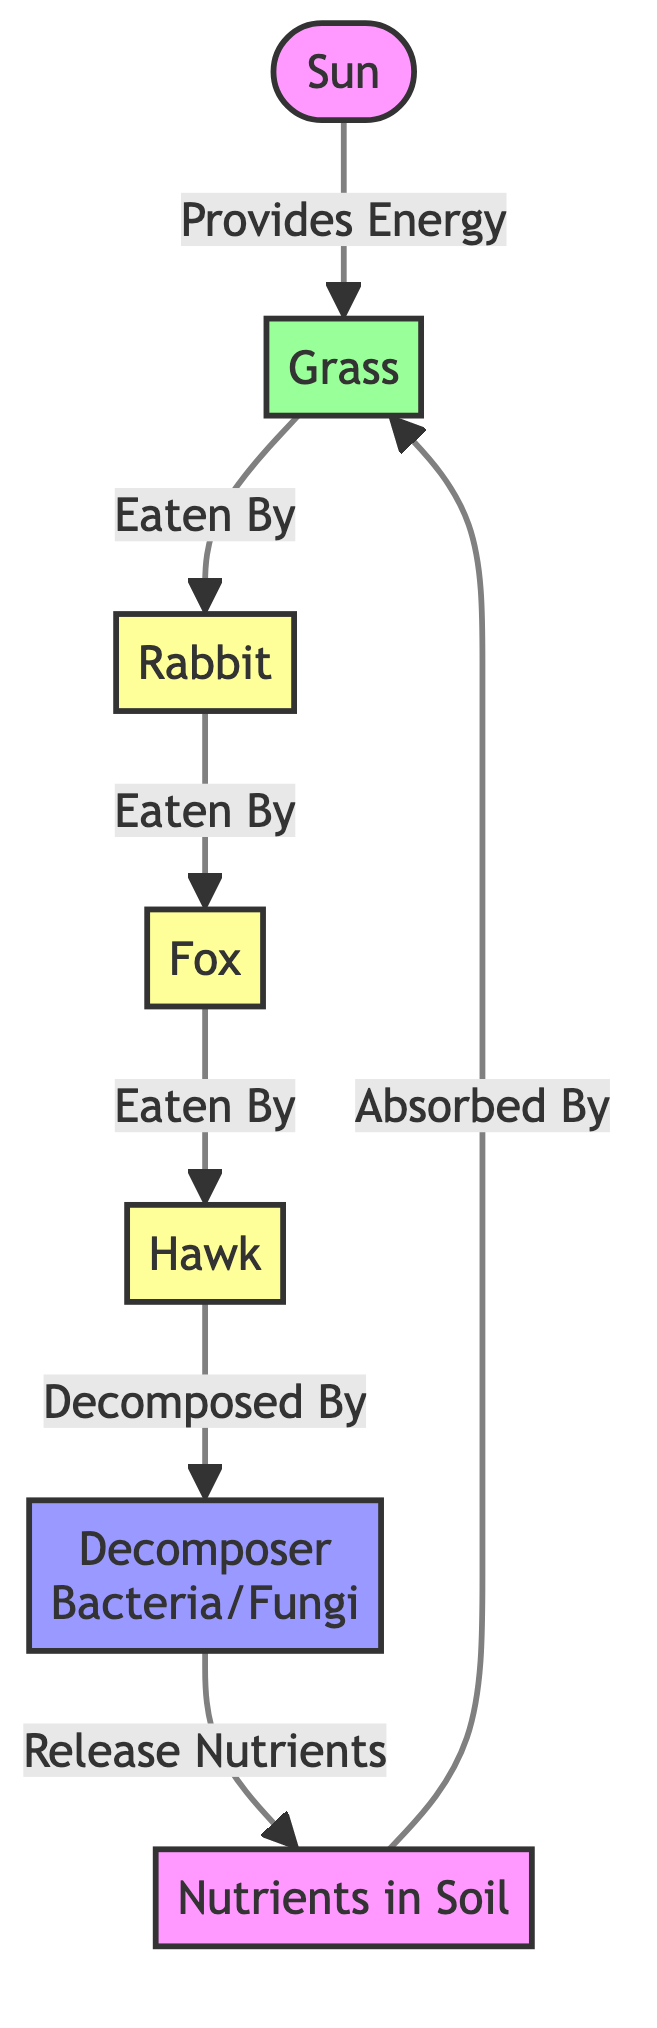What is the primary energy source in this food chain? The diagram shows the sun as the starting point, indicating it provides energy to the grass, which is the first producer in the food chain.
Answer: Sun How many consumers are represented in the diagram? By counting the nodes labeled as consumers, we see that there are three: rabbit, fox, and hawk.
Answer: 3 Which organism is at the top of this food chain? The hawk is shown as the final consumer in the diagram, indicating it is at the top of the food chain.
Answer: Hawk What does the decomposer release back into the ecosystem? The diagram indicates that the decomposer releases nutrients back into the soil, which are essential for the growth of producers like grass.
Answer: Nutrients What role does grass play in this ecosystem? Grass is categorized as a producer in the diagram, meaning it converts sunlight into energy through photosynthesis and serves as the primary food source for herbivores.
Answer: Producer Which type of organisms eat the rabbit in this food chain? The diagram indicates that the fox and hawk consume the rabbit, making them both predators of this particular consumer.
Answer: Fox, Hawk What happens to the nutrients after being released by the decomposer? According to the diagram, the released nutrients in the soil are then absorbed by the grass, demonstrating a cycling of nutrients between producers and decomposers.
Answer: Absorbed By Grass How does energy flow from the sun to the hawk? Energy flows from the sun to grass, then to the rabbit as it eats the grass, followed by the fox eating the rabbit, and finally the hawk consuming the fox, thus highlighting food chain dynamics.
Answer: Through Grass, Rabbit, Fox How many types of organisms are depicted in this diagram? The diagram includes three types of organisms: producers (grass), consumers (rabbit, fox, hawk), and decomposers (bacteria/fungi), totaling three distinct groups.
Answer: 3 Types 